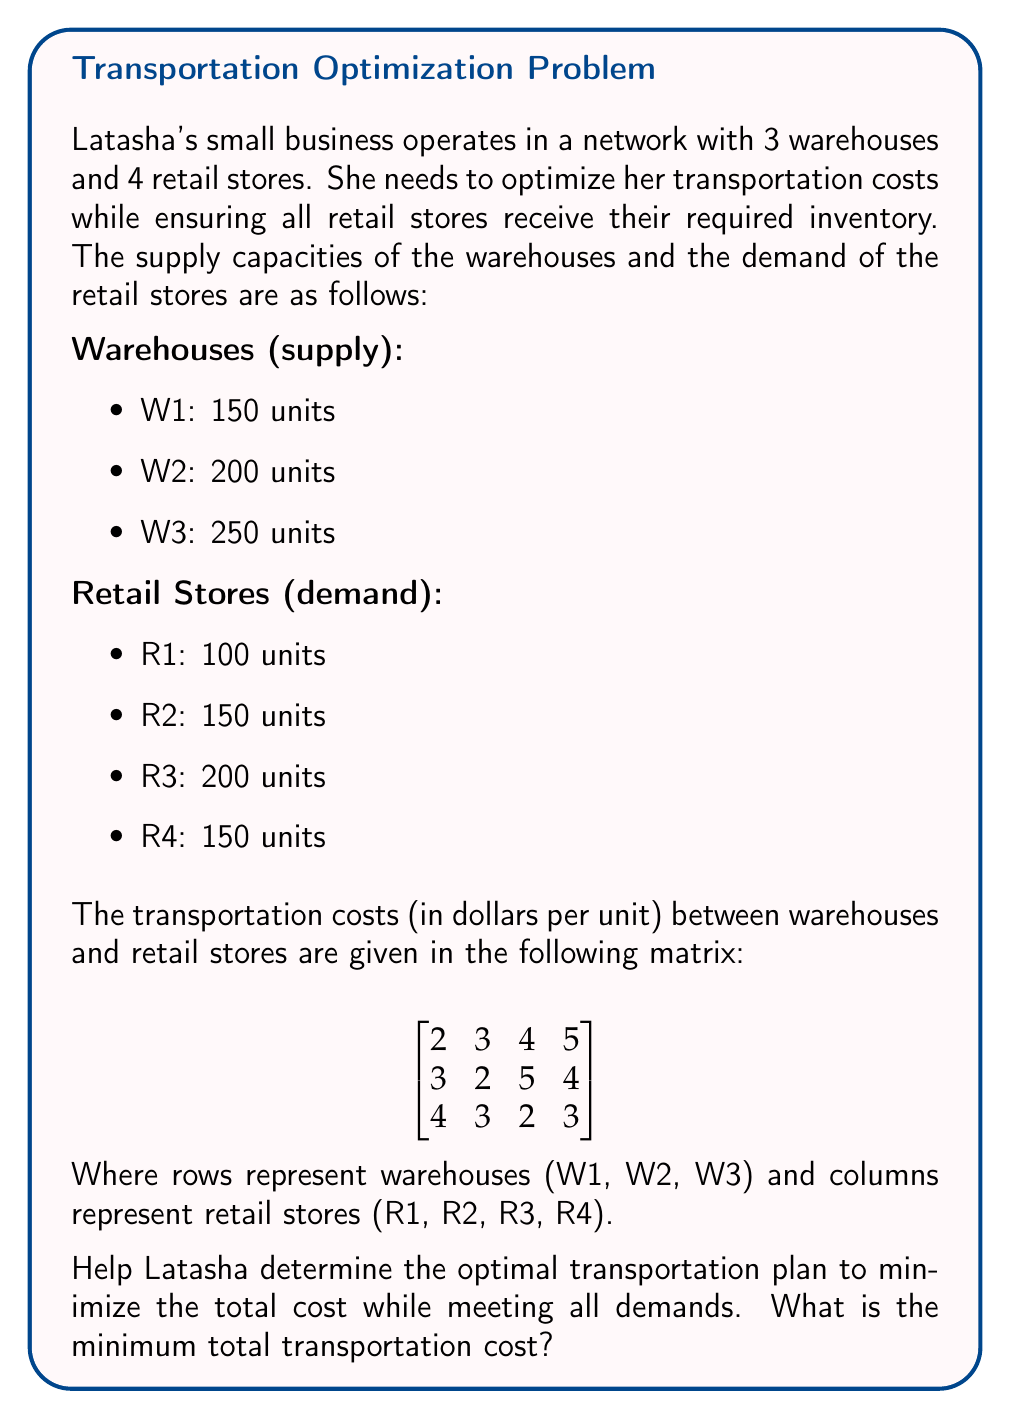Teach me how to tackle this problem. To solve this transportation problem and support Latasha in optimizing her logistics, we'll use the Northwest Corner Method to find an initial feasible solution, then apply the Stepping Stone Method to optimize it.

Step 1: Set up the initial tableau

[asy]
unitsize(1cm);
defaultpen(fontsize(10pt));

string[] rows = {"W1", "W2", "W3", "Demand"};
string[] cols = {"R1", "R2", "R3", "R4", "Supply"};

for (int i = 0; i < 5; ++i) {
  for (int j = 0; j < 6; ++j) {
    draw((i,j)--(i+1,j)--(i+1,j+1)--(i,j+1)--cycle);
  }
}

for (int i = 0; i < 4; ++i) {
  label(rows[i], (-0.5, 4.5-i));
  label(cols[i], (i+0.5, 5.5));
}
label(cols[4], (4.5, 5.5));

label("2", (0.5,4.8));
label("3", (1.5,4.8));
label("4", (2.5,4.8));
label("5", (3.5,4.8));
label("150", (4.5,4.5));

label("3", (0.5,3.8));
label("2", (1.5,3.8));
label("5", (2.5,3.8));
label("4", (3.5,3.8));
label("200", (4.5,3.5));

label("4", (0.5,2.8));
label("3", (1.5,2.8));
label("2", (2.5,2.8));
label("3", (3.5,2.8));
label("250", (4.5,2.5));

label("100", (0.5,1.5));
label("150", (1.5,1.5));
label("200", (2.5,1.5));
label("150", (3.5,1.5));
[/asy]

Step 2: Apply the Northwest Corner Method

[asy]
unitsize(1cm);
defaultpen(fontsize(10pt));

string[] rows = {"W1", "W2", "W3", "Demand"};
string[] cols = {"R1", "R2", "R3", "R4", "Supply"};

for (int i = 0; i < 5; ++i) {
  for (int j = 0; j < 6; ++j) {
    draw((i,j)--(i+1,j)--(i+1,j+1)--(i,j+1)--cycle);
  }
}

for (int i = 0; i < 4; ++i) {
  label(rows[i], (-0.5, 4.5-i));
  label(cols[i], (i+0.5, 5.5));
}
label(cols[4], (4.5, 5.5));

label("2", (0.5,4.8));
label("3", (1.5,4.8));
label("4", (2.5,4.8));
label("5", (3.5,4.8));
label("150", (4.5,4.5));

label("3", (0.5,3.8));
label("2", (1.5,3.8));
label("5", (2.5,3.8));
label("4", (3.5,3.8));
label("200", (4.5,3.5));

label("4", (0.5,2.8));
label("3", (1.5,2.8));
label("2", (2.5,2.8));
label("3", (3.5,2.8));
label("250", (4.5,2.5));

label("100", (0.5,1.5));
label("150", (1.5,1.5));
label("200", (2.5,1.5));
label("150", (3.5,1.5));

label("100", (0.5,4.5));
label("50", (1.5,4.5));
label("100", (1.5,3.5));
label("100", (2.5,3.5));
label("150", (3.5,3.5));
label("100", (2.5,2.5));
label("150", (3.5,2.5));
[/asy]

Step 3: Calculate the initial cost
Initial Cost = 100(2) + 50(3) + 100(2) + 100(5) + 150(4) + 100(2) + 150(3) = 2050

Step 4: Check for optimality using the Stepping Stone Method
Calculate the opportunity cost for each unused route:
W1-R3: +4 -5 +4 -3 = 0
W1-R4: +5 -4 +2 -3 = 0
W2-R1: +3 -2 +3 -4 = 0
W3-R1: +4 -2 +5 -3 -4 = 0
W3-R2: +3 -2 +5 -2 -4 = 0

Since all opportunity costs are non-negative, the current solution is optimal.

Step 5: Verify the solution
Total units transported: 100 + 50 + 100 + 100 + 150 + 100 + 150 = 750
This matches the total supply and demand.

Therefore, the minimum total transportation cost is $2050.
Answer: The minimum total transportation cost for Latasha's small business is $2050. 